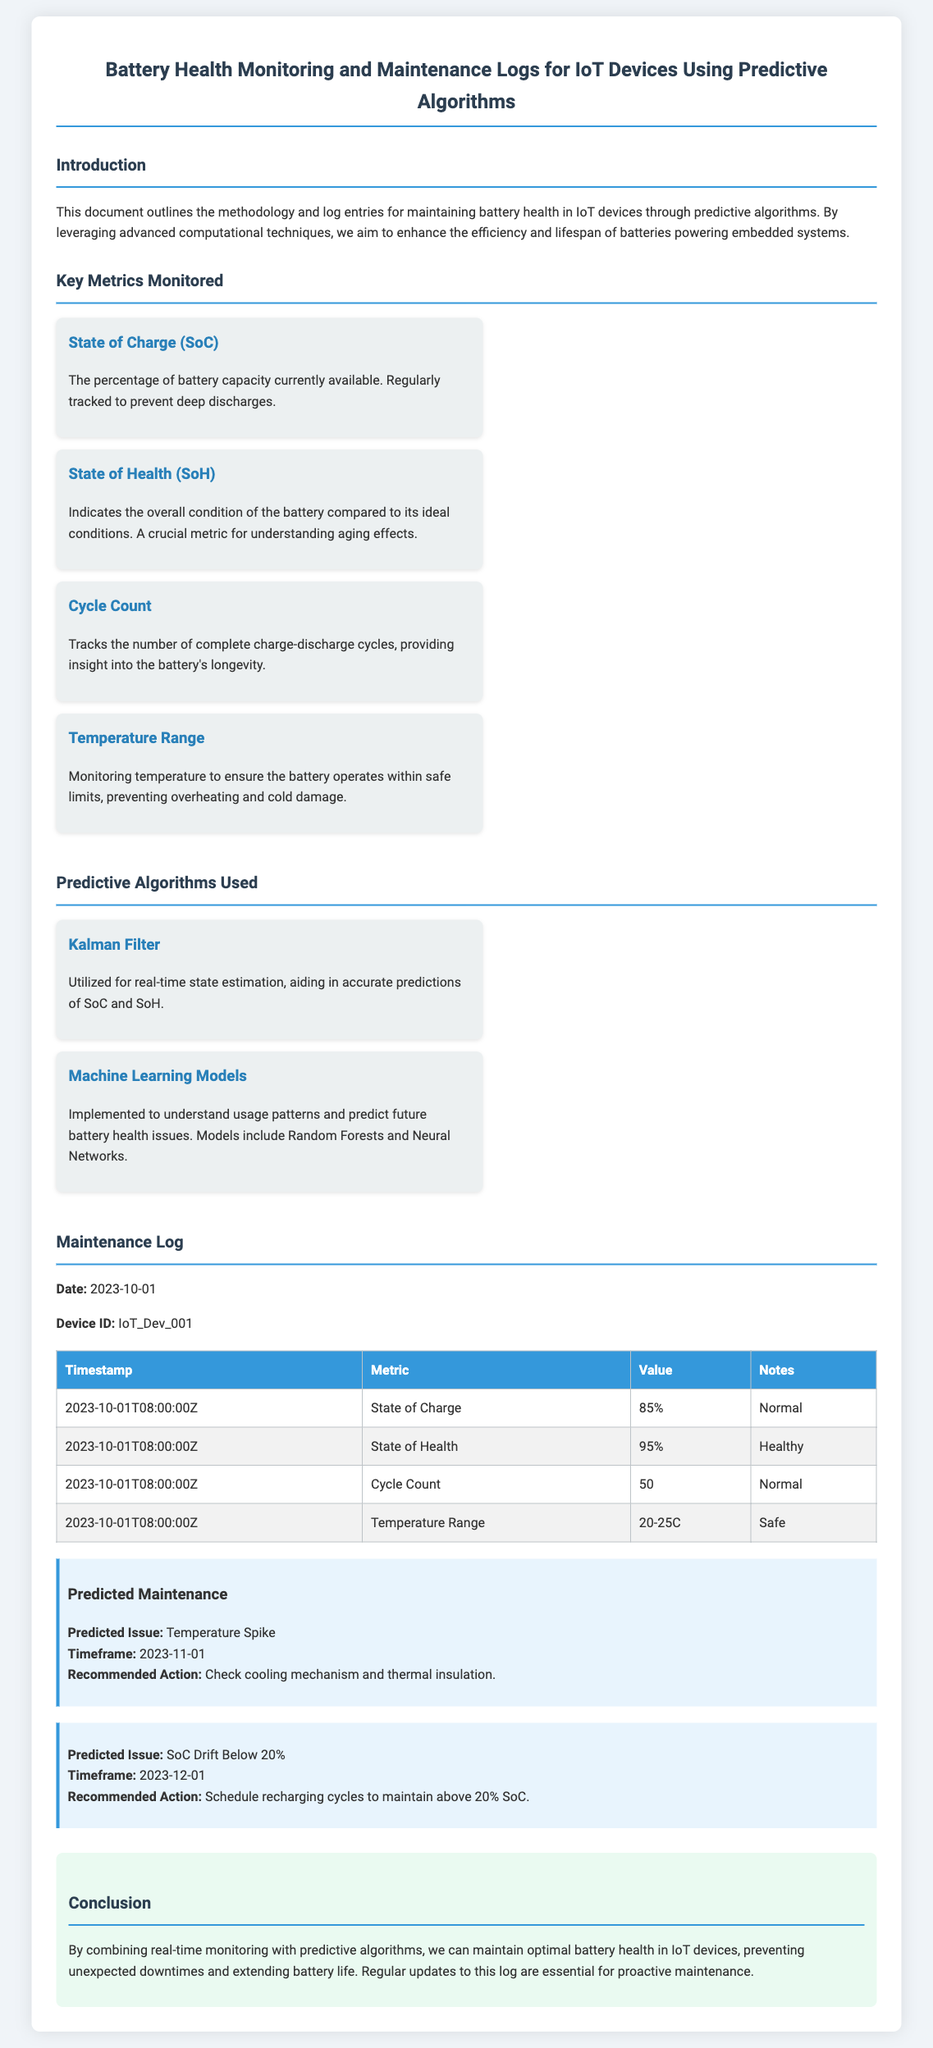what is the title of the document? The title is presented at the top of the document.
Answer: Battery Health Monitoring and Maintenance Logs for IoT Devices Using Predictive Algorithms what is the date of the maintenance log entry? The specific date is mentioned in the maintenance log section.
Answer: 2023-10-01 what is the State of Health (SoH) value recorded in the log? It indicates the overall condition of the battery as per the log entry.
Answer: 95% which algorithm is used for real-time state estimation? The predictive algorithms section describes their functions and purposes.
Answer: Kalman Filter what is the recommended action for the predicted issue of a SoC drift? This is mentioned in the prediction section under the predicted issue.
Answer: Schedule recharging cycles to maintain above 20% SoC how many complete charge-discharge cycles have been counted? This information is found in the maintenance log table.
Answer: 50 what is the temperature range monitored during the log entry? The specific range is listed under the temperature metrics in the log.
Answer: 20-25C what is the predicted timeframe for the temperature spike issue? The timeframe is stated in the predicted maintenance section.
Answer: 2023-11-01 what is the key objective stated in the introduction? The introduction outlines the main goal of the document.
Answer: Enhance the efficiency and lifespan of batteries 